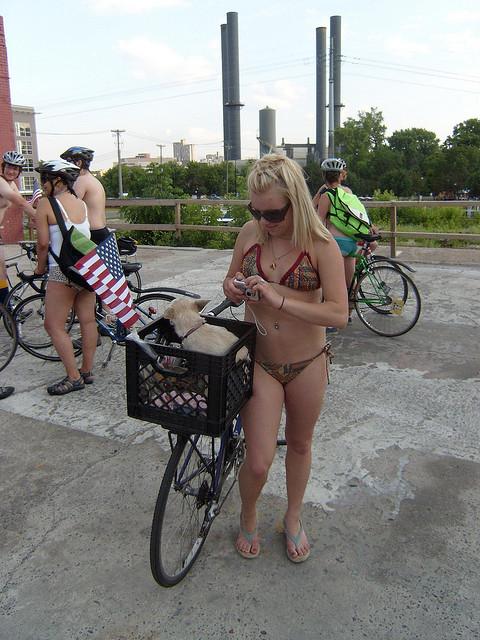Why is he shirtless?
Answer briefly. Hot. What is the basket?
Concise answer only. Dog. What is the blonde woman wearing?
Concise answer only. Bikini. Is it daytime?
Concise answer only. Yes. 